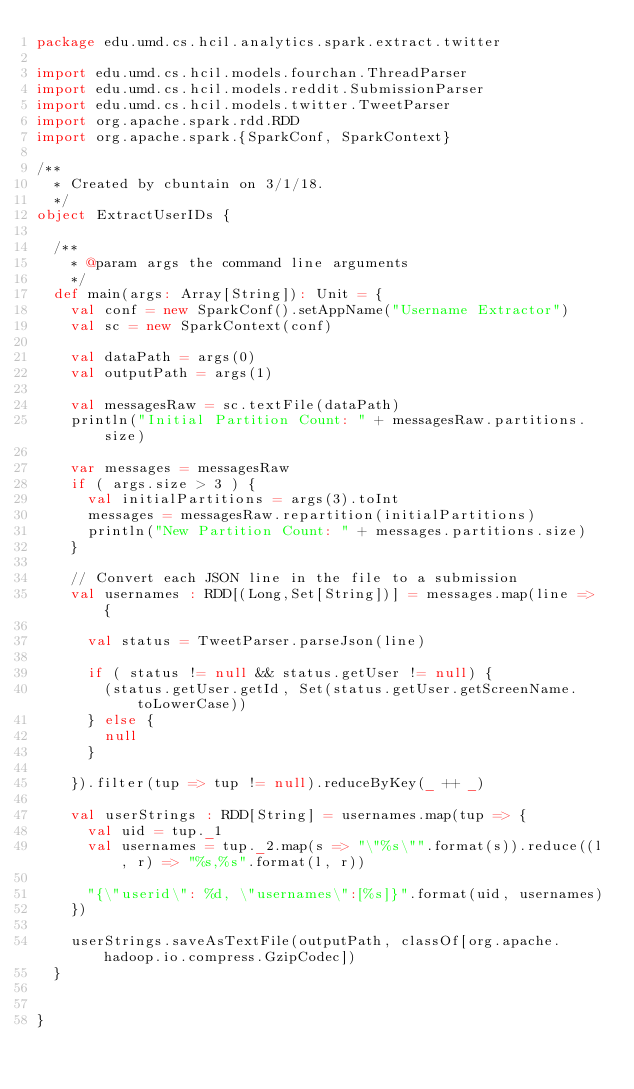Convert code to text. <code><loc_0><loc_0><loc_500><loc_500><_Scala_>package edu.umd.cs.hcil.analytics.spark.extract.twitter

import edu.umd.cs.hcil.models.fourchan.ThreadParser
import edu.umd.cs.hcil.models.reddit.SubmissionParser
import edu.umd.cs.hcil.models.twitter.TweetParser
import org.apache.spark.rdd.RDD
import org.apache.spark.{SparkConf, SparkContext}

/**
  * Created by cbuntain on 3/1/18.
  */
object ExtractUserIDs {

  /**
    * @param args the command line arguments
    */
  def main(args: Array[String]): Unit = {
    val conf = new SparkConf().setAppName("Username Extractor")
    val sc = new SparkContext(conf)

    val dataPath = args(0)
    val outputPath = args(1)

    val messagesRaw = sc.textFile(dataPath)
    println("Initial Partition Count: " + messagesRaw.partitions.size)

    var messages = messagesRaw
    if ( args.size > 3 ) {
      val initialPartitions = args(3).toInt
      messages = messagesRaw.repartition(initialPartitions)
      println("New Partition Count: " + messages.partitions.size)
    }

    // Convert each JSON line in the file to a submission
    val usernames : RDD[(Long,Set[String])] = messages.map(line => {

      val status = TweetParser.parseJson(line)

      if ( status != null && status.getUser != null) {
        (status.getUser.getId, Set(status.getUser.getScreenName.toLowerCase))
      } else {
        null
      }

    }).filter(tup => tup != null).reduceByKey(_ ++ _)

    val userStrings : RDD[String] = usernames.map(tup => {
      val uid = tup._1
      val usernames = tup._2.map(s => "\"%s\"".format(s)).reduce((l, r) => "%s,%s".format(l, r))

      "{\"userid\": %d, \"usernames\":[%s]}".format(uid, usernames)
    })

    userStrings.saveAsTextFile(outputPath, classOf[org.apache.hadoop.io.compress.GzipCodec])
  }


}
</code> 